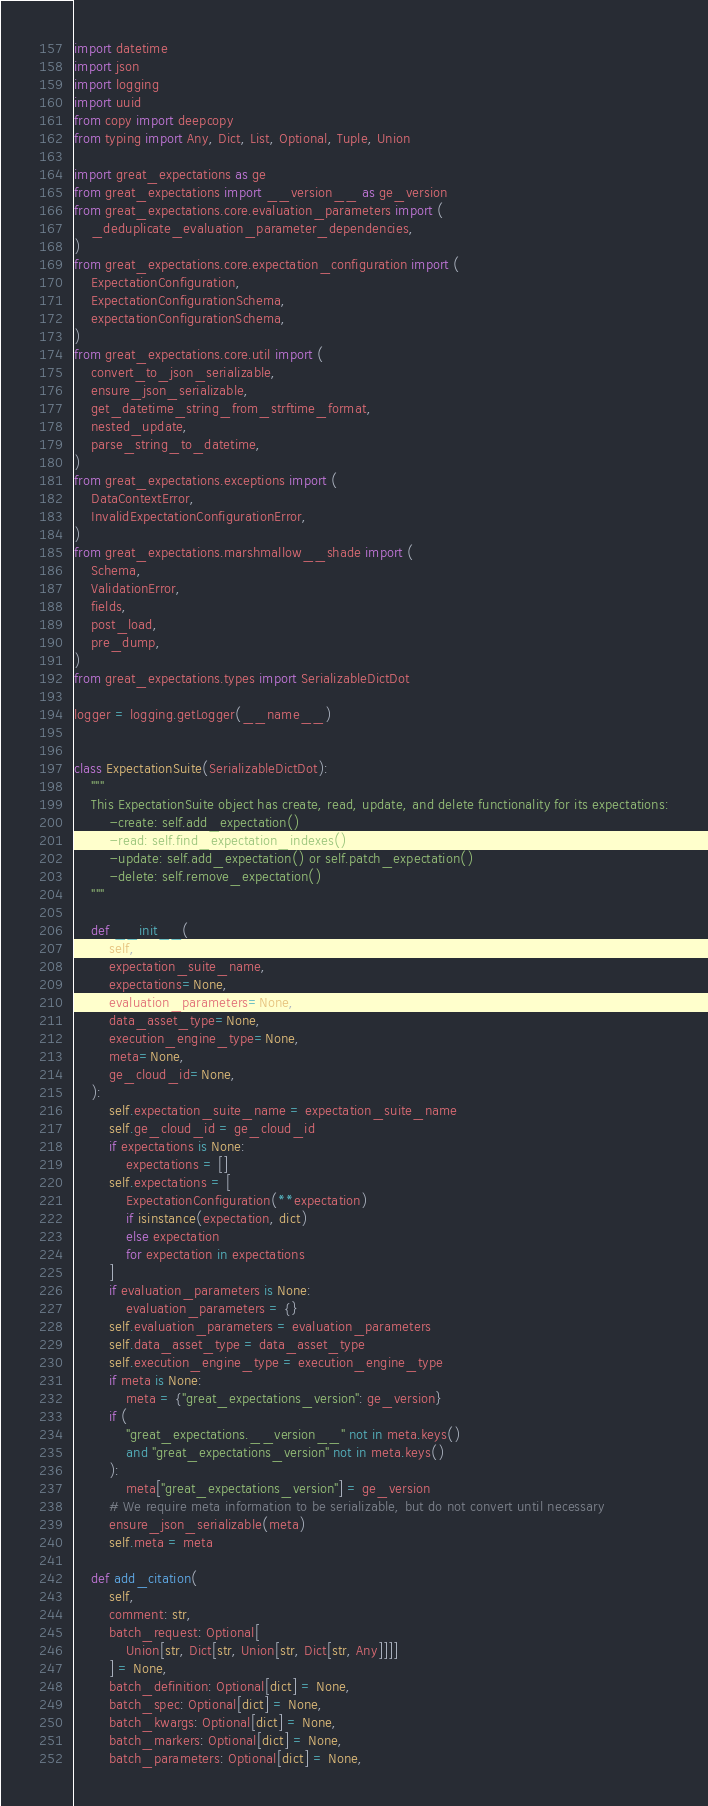Convert code to text. <code><loc_0><loc_0><loc_500><loc_500><_Python_>import datetime
import json
import logging
import uuid
from copy import deepcopy
from typing import Any, Dict, List, Optional, Tuple, Union

import great_expectations as ge
from great_expectations import __version__ as ge_version
from great_expectations.core.evaluation_parameters import (
    _deduplicate_evaluation_parameter_dependencies,
)
from great_expectations.core.expectation_configuration import (
    ExpectationConfiguration,
    ExpectationConfigurationSchema,
    expectationConfigurationSchema,
)
from great_expectations.core.util import (
    convert_to_json_serializable,
    ensure_json_serializable,
    get_datetime_string_from_strftime_format,
    nested_update,
    parse_string_to_datetime,
)
from great_expectations.exceptions import (
    DataContextError,
    InvalidExpectationConfigurationError,
)
from great_expectations.marshmallow__shade import (
    Schema,
    ValidationError,
    fields,
    post_load,
    pre_dump,
)
from great_expectations.types import SerializableDictDot

logger = logging.getLogger(__name__)


class ExpectationSuite(SerializableDictDot):
    """
    This ExpectationSuite object has create, read, update, and delete functionality for its expectations:
        -create: self.add_expectation()
        -read: self.find_expectation_indexes()
        -update: self.add_expectation() or self.patch_expectation()
        -delete: self.remove_expectation()
    """

    def __init__(
        self,
        expectation_suite_name,
        expectations=None,
        evaluation_parameters=None,
        data_asset_type=None,
        execution_engine_type=None,
        meta=None,
        ge_cloud_id=None,
    ):
        self.expectation_suite_name = expectation_suite_name
        self.ge_cloud_id = ge_cloud_id
        if expectations is None:
            expectations = []
        self.expectations = [
            ExpectationConfiguration(**expectation)
            if isinstance(expectation, dict)
            else expectation
            for expectation in expectations
        ]
        if evaluation_parameters is None:
            evaluation_parameters = {}
        self.evaluation_parameters = evaluation_parameters
        self.data_asset_type = data_asset_type
        self.execution_engine_type = execution_engine_type
        if meta is None:
            meta = {"great_expectations_version": ge_version}
        if (
            "great_expectations.__version__" not in meta.keys()
            and "great_expectations_version" not in meta.keys()
        ):
            meta["great_expectations_version"] = ge_version
        # We require meta information to be serializable, but do not convert until necessary
        ensure_json_serializable(meta)
        self.meta = meta

    def add_citation(
        self,
        comment: str,
        batch_request: Optional[
            Union[str, Dict[str, Union[str, Dict[str, Any]]]]
        ] = None,
        batch_definition: Optional[dict] = None,
        batch_spec: Optional[dict] = None,
        batch_kwargs: Optional[dict] = None,
        batch_markers: Optional[dict] = None,
        batch_parameters: Optional[dict] = None,</code> 